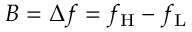<formula> <loc_0><loc_0><loc_500><loc_500>B = \Delta f = f _ { H } - f _ { L }</formula> 